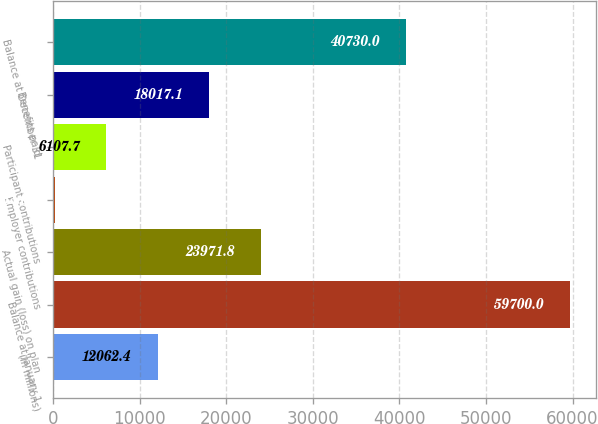Convert chart. <chart><loc_0><loc_0><loc_500><loc_500><bar_chart><fcel>(In millions)<fcel>Balance at January 1<fcel>Actual gain (loss) on plan<fcel>Employer contributions<fcel>Participant contributions<fcel>Benefits paid<fcel>Balance at December 31<nl><fcel>12062.4<fcel>59700<fcel>23971.8<fcel>153<fcel>6107.7<fcel>18017.1<fcel>40730<nl></chart> 